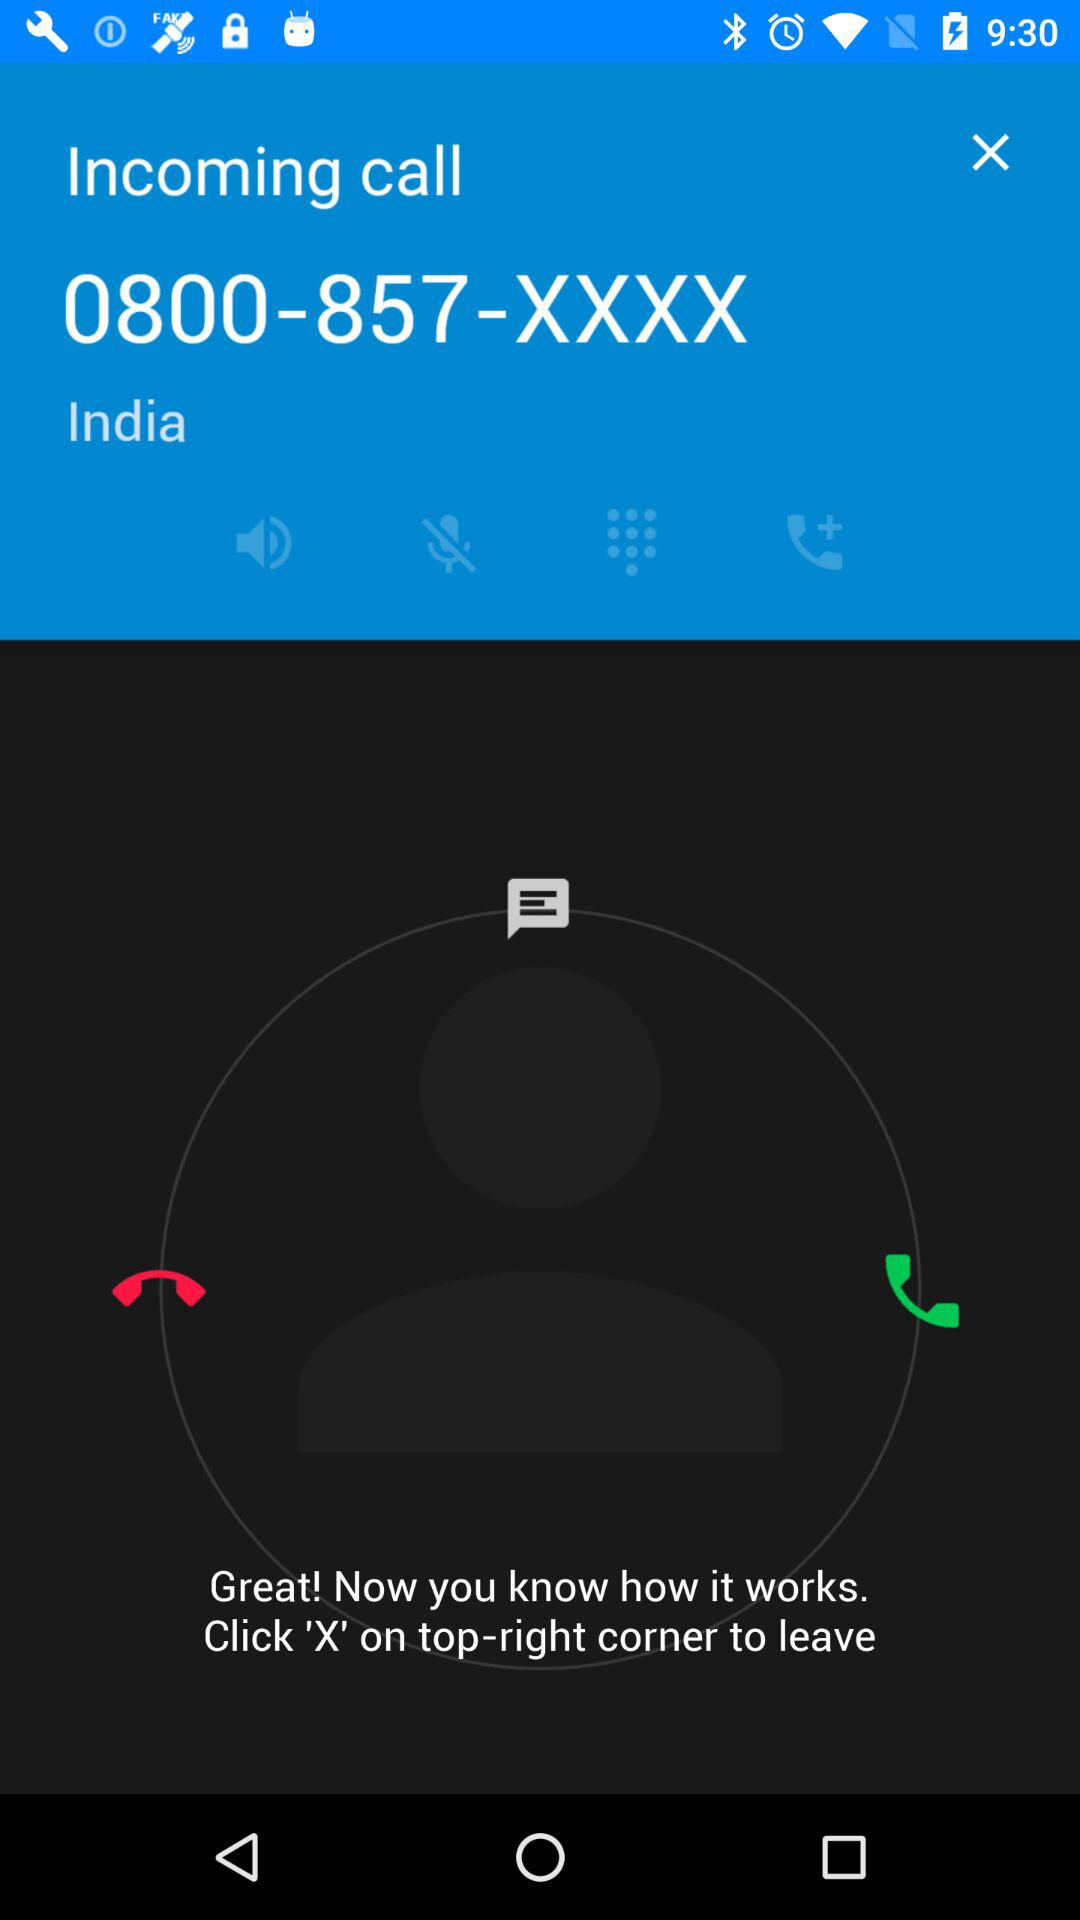What is the number shown on the screen? The number shown on the screen is 0800-857-XXXX. 